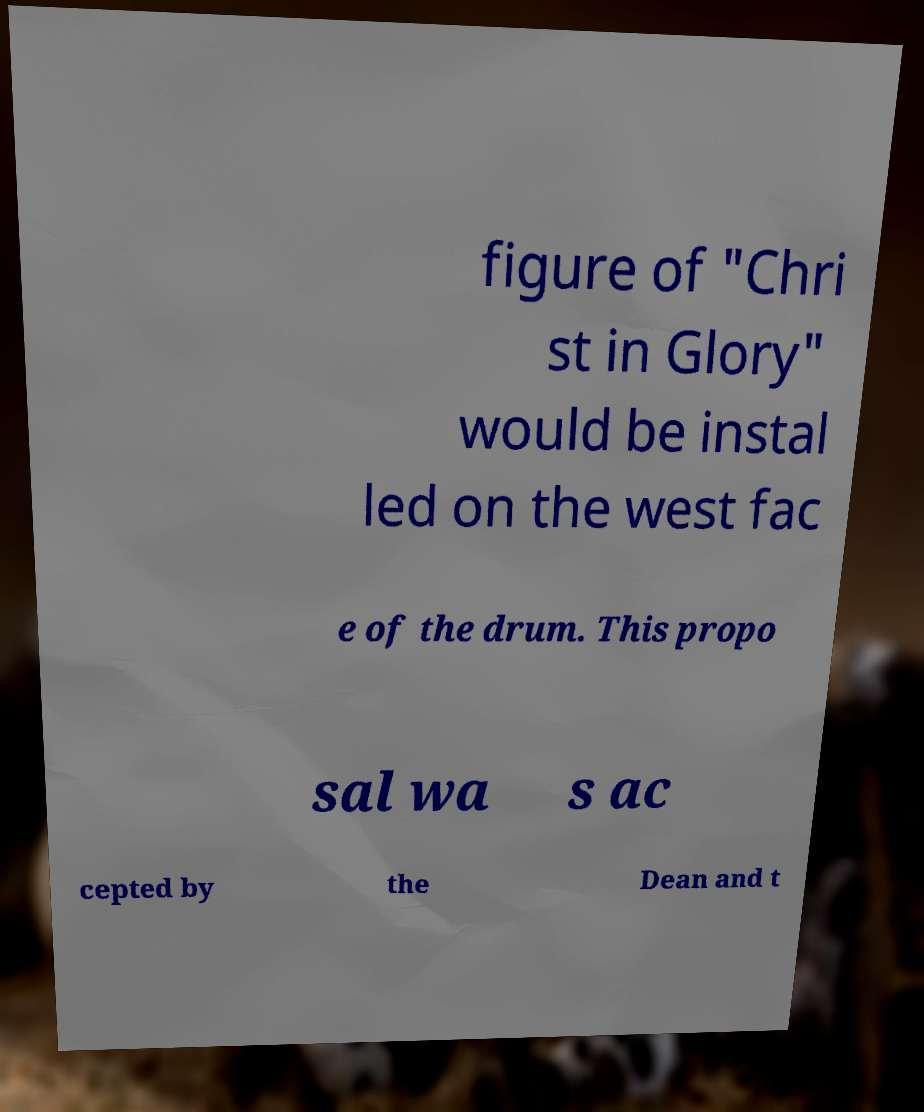Can you read and provide the text displayed in the image?This photo seems to have some interesting text. Can you extract and type it out for me? figure of "Chri st in Glory" would be instal led on the west fac e of the drum. This propo sal wa s ac cepted by the Dean and t 